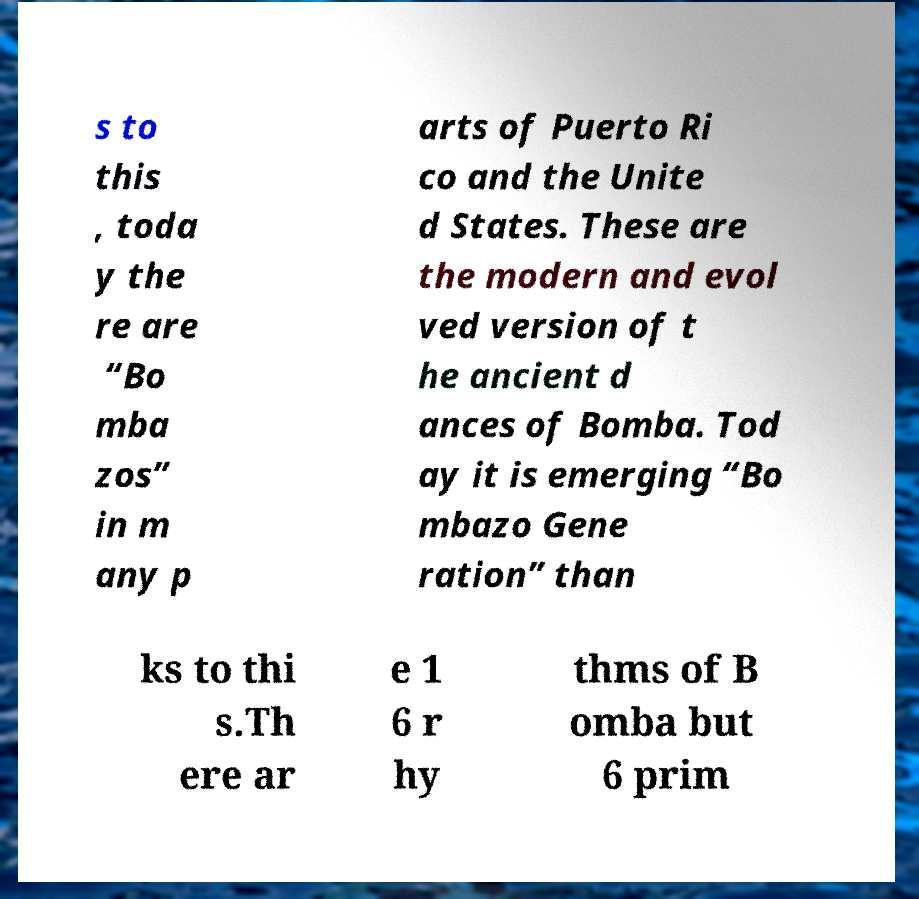Could you assist in decoding the text presented in this image and type it out clearly? s to this , toda y the re are “Bo mba zos” in m any p arts of Puerto Ri co and the Unite d States. These are the modern and evol ved version of t he ancient d ances of Bomba. Tod ay it is emerging “Bo mbazo Gene ration” than ks to thi s.Th ere ar e 1 6 r hy thms of B omba but 6 prim 